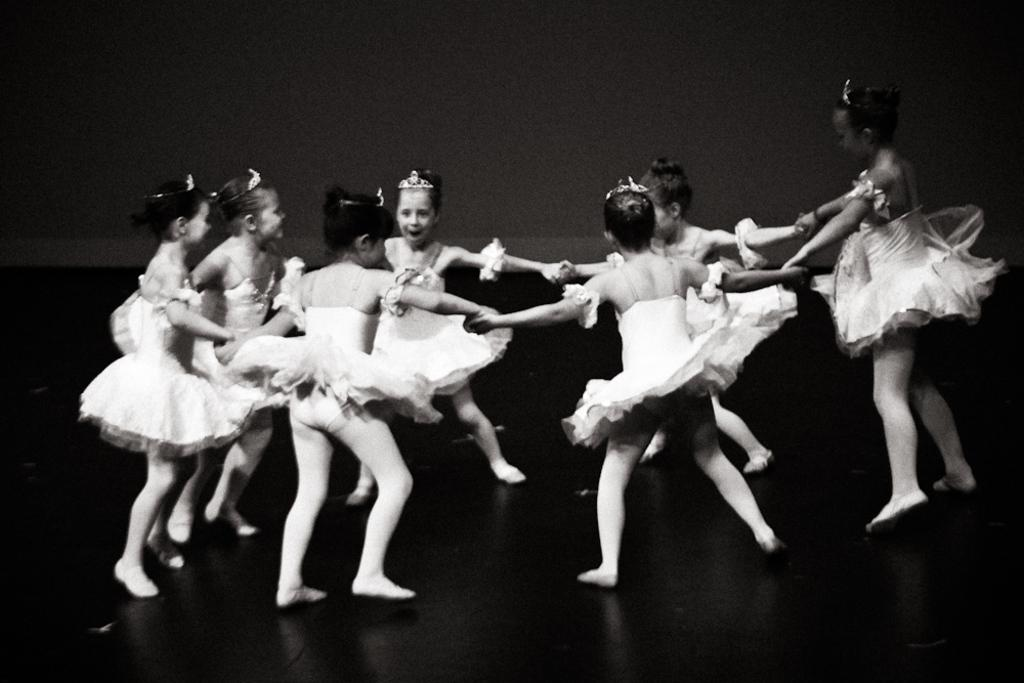What is happening in the image? There are girls in the image, and they are dancing. How are the girls interacting with each other? The girls are holding each other's hands. What type of ornament is hanging from the ceiling in the image? There is no ornament hanging from the ceiling in the image; it only shows girls dancing and holding hands. 